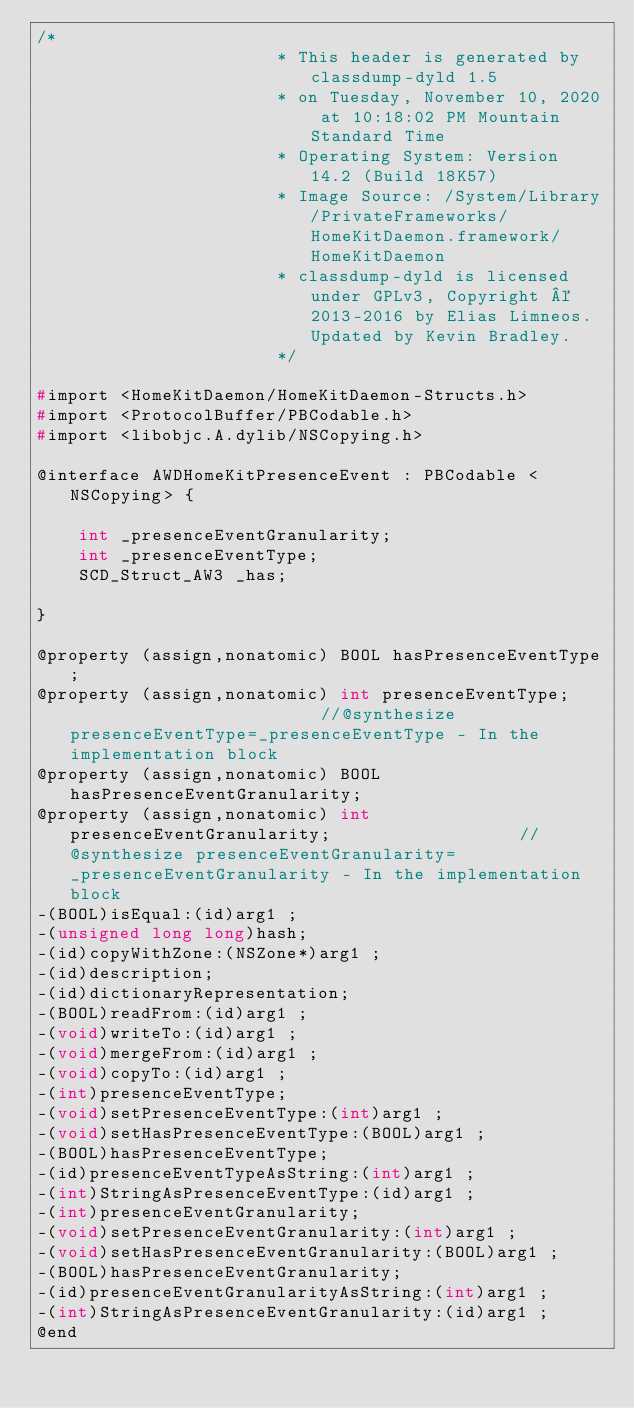<code> <loc_0><loc_0><loc_500><loc_500><_C_>/*
                       * This header is generated by classdump-dyld 1.5
                       * on Tuesday, November 10, 2020 at 10:18:02 PM Mountain Standard Time
                       * Operating System: Version 14.2 (Build 18K57)
                       * Image Source: /System/Library/PrivateFrameworks/HomeKitDaemon.framework/HomeKitDaemon
                       * classdump-dyld is licensed under GPLv3, Copyright © 2013-2016 by Elias Limneos. Updated by Kevin Bradley.
                       */

#import <HomeKitDaemon/HomeKitDaemon-Structs.h>
#import <ProtocolBuffer/PBCodable.h>
#import <libobjc.A.dylib/NSCopying.h>

@interface AWDHomeKitPresenceEvent : PBCodable <NSCopying> {

	int _presenceEventGranularity;
	int _presenceEventType;
	SCD_Struct_AW3 _has;

}

@property (assign,nonatomic) BOOL hasPresenceEventType; 
@property (assign,nonatomic) int presenceEventType;                         //@synthesize presenceEventType=_presenceEventType - In the implementation block
@property (assign,nonatomic) BOOL hasPresenceEventGranularity; 
@property (assign,nonatomic) int presenceEventGranularity;                  //@synthesize presenceEventGranularity=_presenceEventGranularity - In the implementation block
-(BOOL)isEqual:(id)arg1 ;
-(unsigned long long)hash;
-(id)copyWithZone:(NSZone*)arg1 ;
-(id)description;
-(id)dictionaryRepresentation;
-(BOOL)readFrom:(id)arg1 ;
-(void)writeTo:(id)arg1 ;
-(void)mergeFrom:(id)arg1 ;
-(void)copyTo:(id)arg1 ;
-(int)presenceEventType;
-(void)setPresenceEventType:(int)arg1 ;
-(void)setHasPresenceEventType:(BOOL)arg1 ;
-(BOOL)hasPresenceEventType;
-(id)presenceEventTypeAsString:(int)arg1 ;
-(int)StringAsPresenceEventType:(id)arg1 ;
-(int)presenceEventGranularity;
-(void)setPresenceEventGranularity:(int)arg1 ;
-(void)setHasPresenceEventGranularity:(BOOL)arg1 ;
-(BOOL)hasPresenceEventGranularity;
-(id)presenceEventGranularityAsString:(int)arg1 ;
-(int)StringAsPresenceEventGranularity:(id)arg1 ;
@end

</code> 